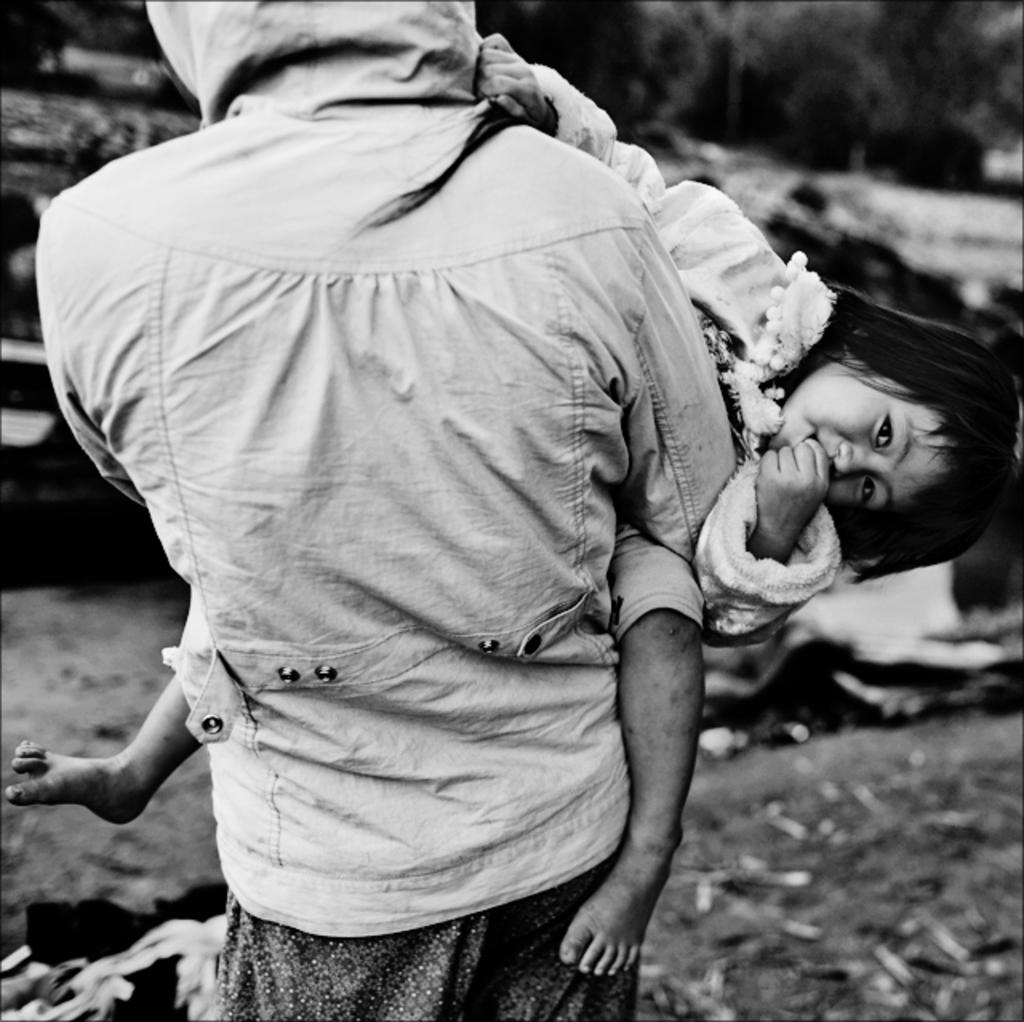What is the color scheme of the image? The image is black and white. What is the person in the image doing? The person is holding a child in the image. Can you describe the background of the image? The background of the image is blurry. What type of book is the person reading to the child in the image? There is no book present in the image, and the person is not reading to the child. 